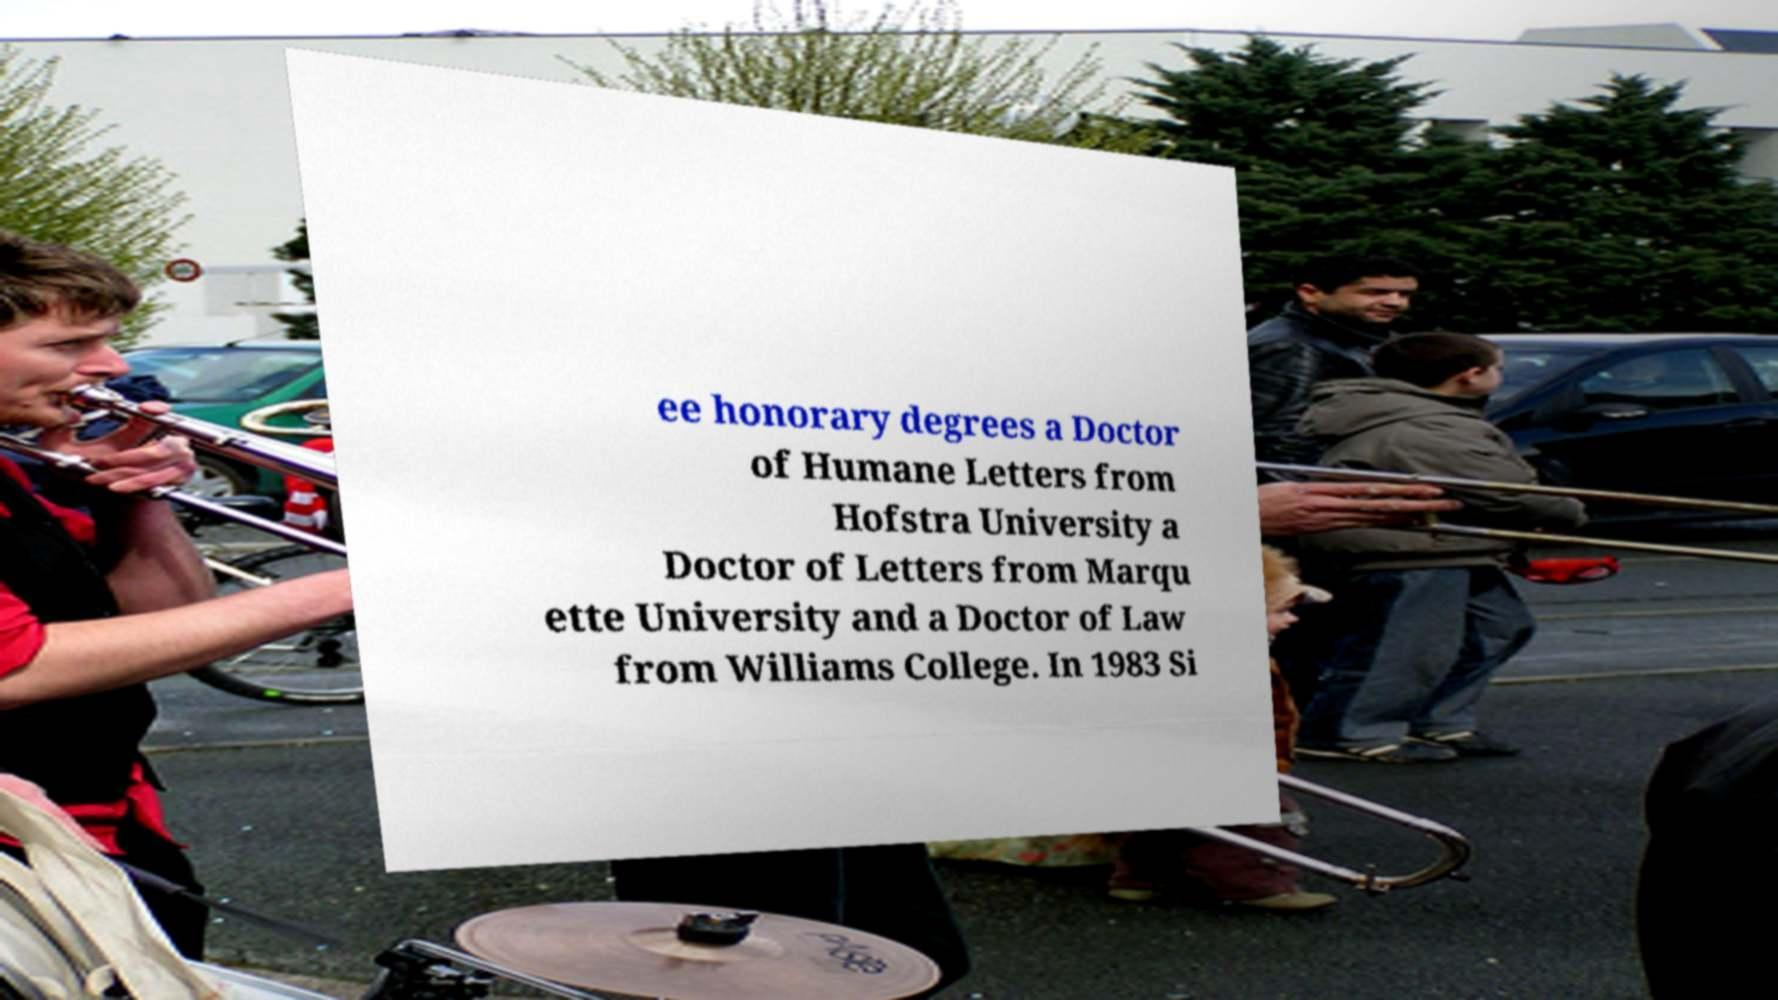Please read and relay the text visible in this image. What does it say? ee honorary degrees a Doctor of Humane Letters from Hofstra University a Doctor of Letters from Marqu ette University and a Doctor of Law from Williams College. In 1983 Si 